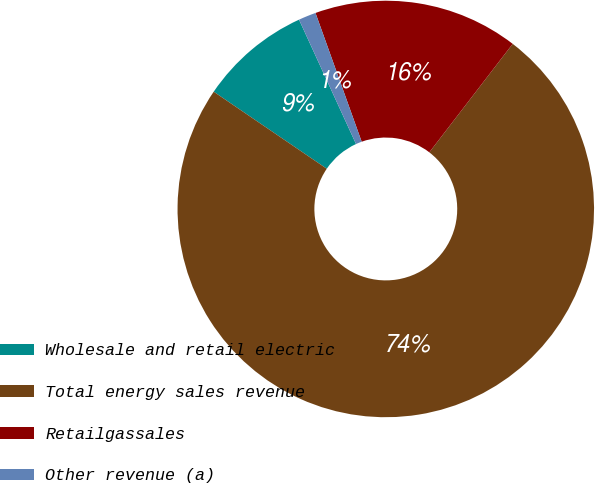Convert chart. <chart><loc_0><loc_0><loc_500><loc_500><pie_chart><fcel>Wholesale and retail electric<fcel>Total energy sales revenue<fcel>Retailgassales<fcel>Other revenue (a)<nl><fcel>8.64%<fcel>74.09%<fcel>15.91%<fcel>1.36%<nl></chart> 